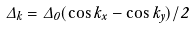<formula> <loc_0><loc_0><loc_500><loc_500>\Delta _ { k } = \Delta _ { 0 } ( \cos k _ { x } - \cos k _ { y } ) / 2</formula> 